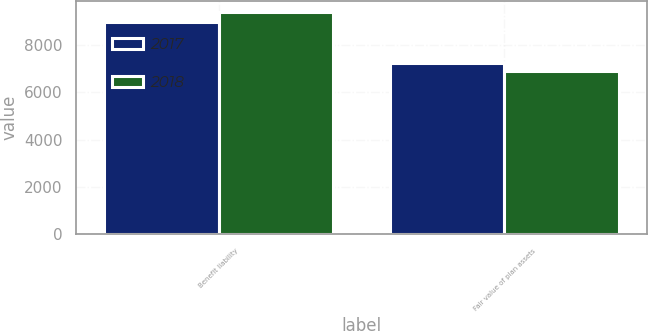Convert chart to OTSL. <chart><loc_0><loc_0><loc_500><loc_500><stacked_bar_chart><ecel><fcel>Benefit liability<fcel>Fair value of plan assets<nl><fcel>2017<fcel>8957<fcel>7223<nl><fcel>2018<fcel>9400<fcel>6919<nl></chart> 